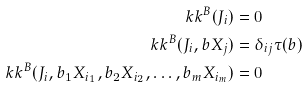Convert formula to latex. <formula><loc_0><loc_0><loc_500><loc_500>\ k k ^ { B } ( J _ { i } ) & = 0 \\ \ k k ^ { B } ( J _ { i } , b X _ { j } ) & = \delta _ { i j } \tau ( b ) \\ \ k k ^ { B } ( J _ { i } , b _ { 1 } X _ { i _ { 1 } } , b _ { 2 } X _ { i _ { 2 } } , \dots , b _ { m } X _ { i _ { m } } ) & = 0</formula> 